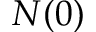<formula> <loc_0><loc_0><loc_500><loc_500>N ( 0 )</formula> 